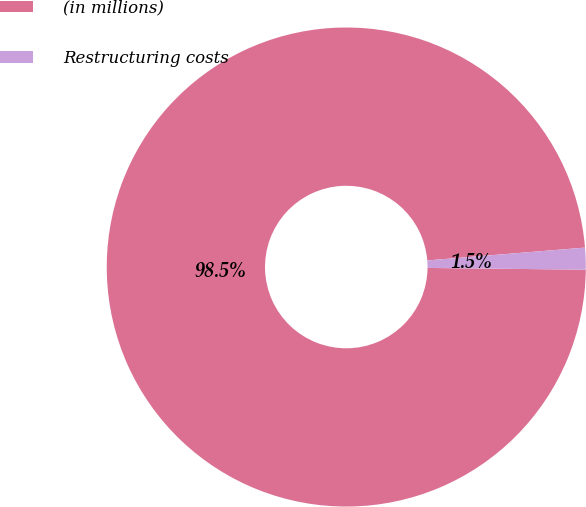Convert chart to OTSL. <chart><loc_0><loc_0><loc_500><loc_500><pie_chart><fcel>(in millions)<fcel>Restructuring costs<nl><fcel>98.53%<fcel>1.47%<nl></chart> 